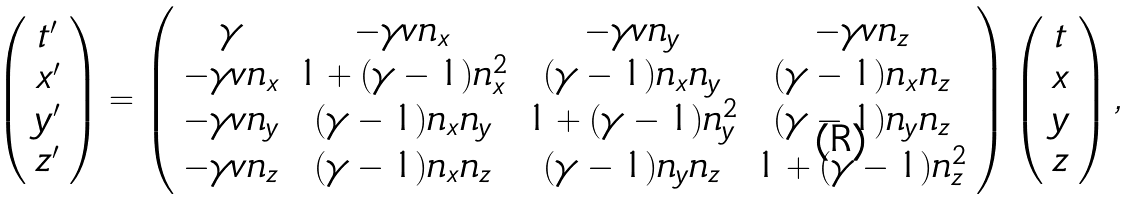<formula> <loc_0><loc_0><loc_500><loc_500>\left ( \begin{array} { c } t ^ { \prime } \\ x ^ { \prime } \\ y ^ { \prime } \\ z ^ { \prime } \end{array} \right ) = \left ( \begin{array} { c c c c } \gamma & - \gamma v n _ { x } & - \gamma v n _ { y } & - \gamma v n _ { z } \\ - \gamma v n _ { x } & 1 + ( \gamma - 1 ) n _ { x } ^ { 2 } & ( \gamma - 1 ) n _ { x } n _ { y } & ( \gamma - 1 ) n _ { x } n _ { z } \\ - \gamma v n _ { y } & ( \gamma - 1 ) n _ { x } n _ { y } & 1 + ( \gamma - 1 ) n _ { y } ^ { 2 } & ( \gamma - 1 ) n _ { y } n _ { z } \\ - \gamma v n _ { z } & ( \gamma - 1 ) n _ { x } n _ { z } & ( \gamma - 1 ) n _ { y } n _ { z } & 1 + ( \gamma - 1 ) n _ { z } ^ { 2 } \\ \end{array} \right ) \left ( \begin{array} { c } t \\ x \\ y \\ z \end{array} \right ) ,</formula> 